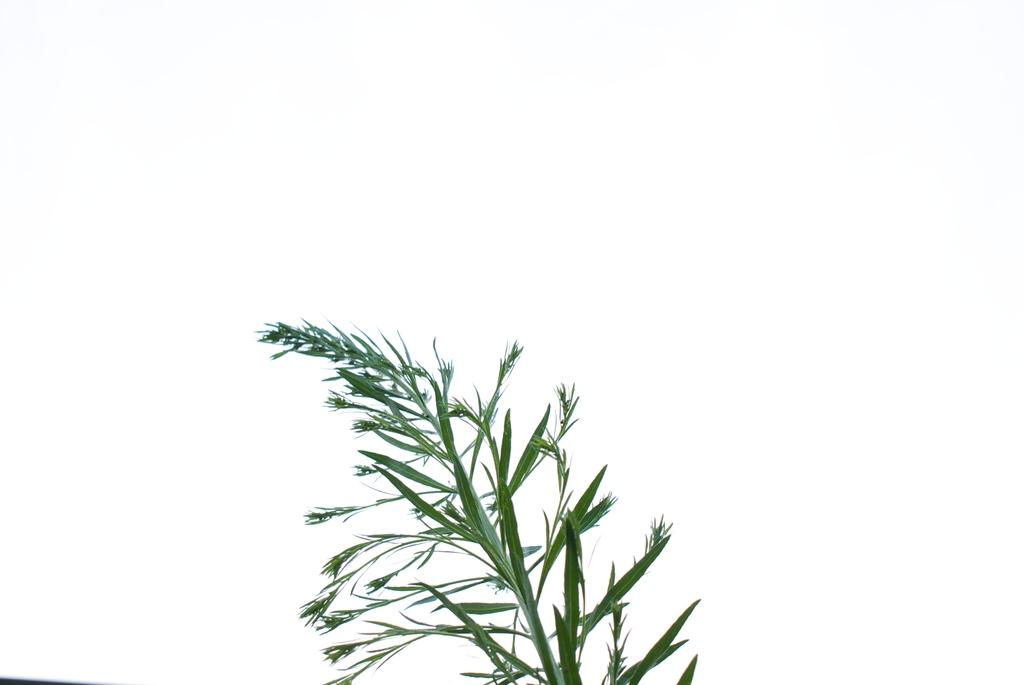What type of living organism can be seen in the image? There is a plant in the image. What color is the background of the image? The background of the image is white. What type of road can be seen in the image? There is no road present in the image; it features a plant and a white background. 